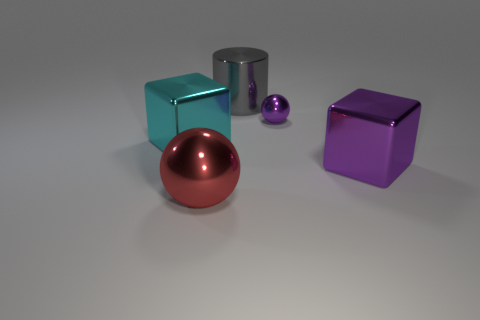Add 2 big brown blocks. How many objects exist? 7 Subtract all blocks. How many objects are left? 3 Add 4 small purple objects. How many small purple objects are left? 5 Add 4 metallic balls. How many metallic balls exist? 6 Subtract 0 cyan cylinders. How many objects are left? 5 Subtract all big green objects. Subtract all small purple balls. How many objects are left? 4 